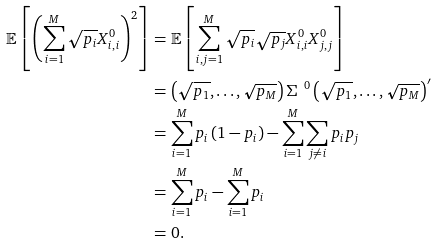<formula> <loc_0><loc_0><loc_500><loc_500>\mathbb { E } \left [ \left ( \sum _ { i = 1 } ^ { M } \sqrt { p _ { i } } { X } ^ { 0 } _ { i , i } \right ) ^ { 2 } \right ] & = \mathbb { E } \left [ \sum _ { i , j = 1 } ^ { M } \sqrt { p _ { i } } \sqrt { p _ { j } } { X } ^ { 0 } _ { i , i } { X } ^ { 0 } _ { j , j } \right ] \\ & = \left ( \sqrt { p _ { 1 } } , \dots , \sqrt { p _ { M } } \right ) { \Sigma } ^ { \ \, 0 } \left ( \sqrt { p _ { 1 } } , \dots , \sqrt { p _ { M } } \right ) ^ { \prime } \\ & = \sum _ { i = 1 } ^ { M } p _ { i } \left ( 1 - p _ { i } \right ) - \sum _ { i = 1 } ^ { M } \sum _ { j \ne i } p _ { i } p _ { j } \\ & = \sum _ { i = 1 } ^ { M } p _ { i } - \sum _ { i = 1 } ^ { M } p _ { i } \\ & = 0 .</formula> 